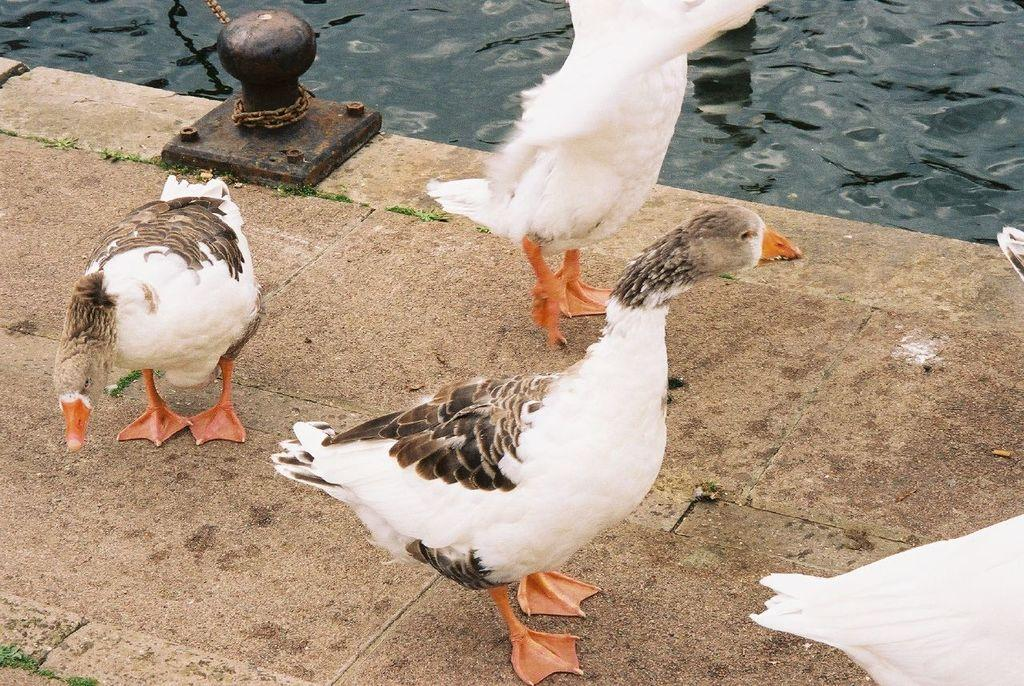What type of animals can be seen in the image? There are birds in the image. What colors are the birds? The birds are in white and brown color. What can be seen in the background of the image? There is an iron object and water visible in the background of the image. What type of dust can be seen on the birds' wings in the image? There is no dust visible on the birds' wings in the image. How many hens are present in the image? There is no hen present in the image; only birds are visible. 